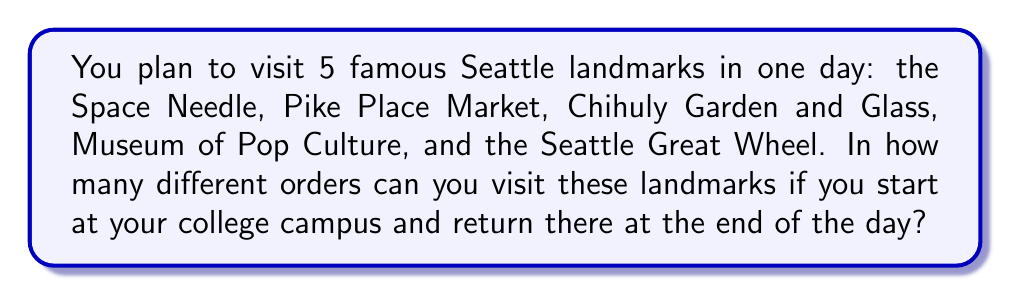Teach me how to tackle this problem. Let's approach this step-by-step:

1) First, we need to recognize that this is a permutation problem. We're arranging all 5 landmarks in different orders.

2) The key here is that we're starting and ending at the college campus, which means the order of the 5 landmarks is what matters, not the starting or ending point.

3) When we have n distinct objects to arrange in order, the number of permutations is given by:

   $$P(n) = n!$$

4) In this case, we have 5 landmarks to arrange, so n = 5.

5) Therefore, the number of different routes is:

   $$P(5) = 5! = 5 \times 4 \times 3 \times 2 \times 1 = 120$$

6) We can interpret this as:
   - We have 5 choices for the first landmark
   - Then 4 choices for the second
   - 3 for the third
   - 2 for the fourth
   - And only 1 choice left for the last landmark

7) Multiplying these together gives us 5! = 120 different routes.
Answer: 120 